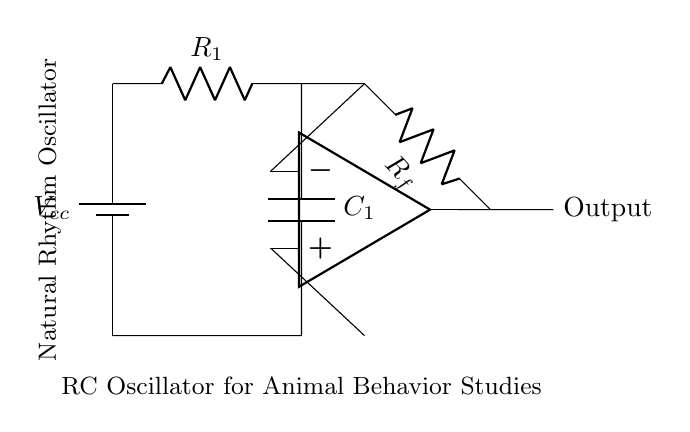What type of circuit is shown in the diagram? The circuit is an oscillator, specifically an RC oscillator, used for generating periodic signals. This can be determined by the arrangement of resistors and capacitors creating an oscillating output.
Answer: Oscillator What is the supply voltage indicated in the diagram? The supply voltage, denoted as Vcc, is indicated to be the standard voltage source for the circuit. In most circuits, this is typically a specific voltage value, but without a numerical value specified, it remains as Vcc.
Answer: Vcc How many resistors are present in the circuit? Counting the components, there are two resistors labeled R1 and Rf. The presence of two distinct resistor components can be observed in the circuit diagram, thus leading to the conclusion.
Answer: Two What role does the capacitor play in this circuit? The capacitor C1 is a key component in determining the timing of the oscillations in the circuit, affecting the charge and discharge cycle contributing to frequency generation. Thus, its role in storing and releasing energy reflects on the oscillation behavior.
Answer: Frequency determination Is there an operational amplifier in this circuit? The circuit includes one operational amplifier, indicated by the op amp symbol. The presence of the op amp, along with its inputs and output connections, clearly identifies its role in amplification and feedback control within the oscillator.
Answer: Yes What is the function of the feedback resistor Rf? The feedback resistor Rf is instrumental in controlling the gain of the amplifier and stabilizing the oscillation frequency. Its value directly influences the overall behavior of the circuit, providing necessary feedback to sustain the oscillation.
Answer: Gain control What does the output label indicate in this circuit? The output label signifies where the oscillating signal generated by the circuit can be accessed. This output provides the periodic waveform meant for further use in studies, aligning with the circuit's design purpose.
Answer: Output 